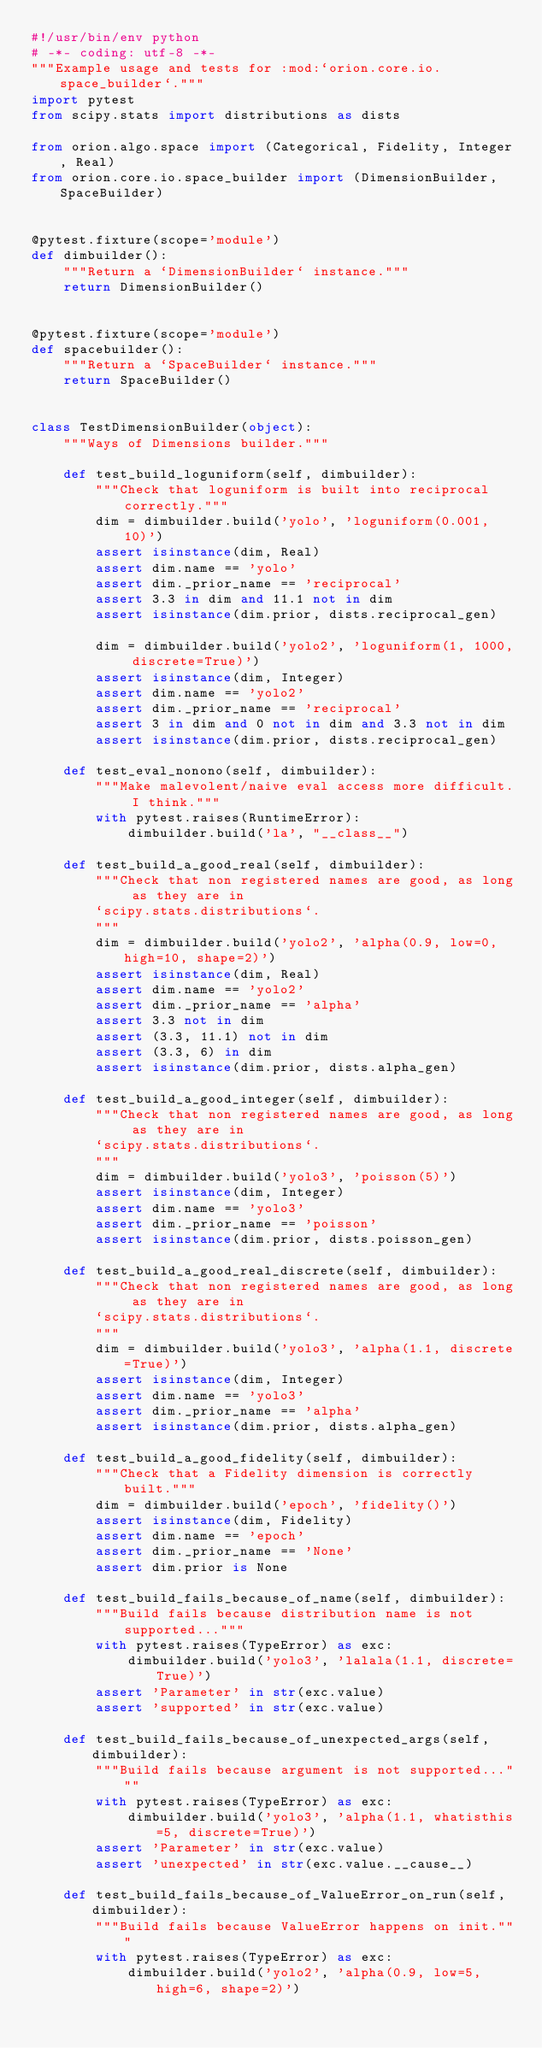<code> <loc_0><loc_0><loc_500><loc_500><_Python_>#!/usr/bin/env python
# -*- coding: utf-8 -*-
"""Example usage and tests for :mod:`orion.core.io.space_builder`."""
import pytest
from scipy.stats import distributions as dists

from orion.algo.space import (Categorical, Fidelity, Integer, Real)
from orion.core.io.space_builder import (DimensionBuilder, SpaceBuilder)


@pytest.fixture(scope='module')
def dimbuilder():
    """Return a `DimensionBuilder` instance."""
    return DimensionBuilder()


@pytest.fixture(scope='module')
def spacebuilder():
    """Return a `SpaceBuilder` instance."""
    return SpaceBuilder()


class TestDimensionBuilder(object):
    """Ways of Dimensions builder."""

    def test_build_loguniform(self, dimbuilder):
        """Check that loguniform is built into reciprocal correctly."""
        dim = dimbuilder.build('yolo', 'loguniform(0.001, 10)')
        assert isinstance(dim, Real)
        assert dim.name == 'yolo'
        assert dim._prior_name == 'reciprocal'
        assert 3.3 in dim and 11.1 not in dim
        assert isinstance(dim.prior, dists.reciprocal_gen)

        dim = dimbuilder.build('yolo2', 'loguniform(1, 1000, discrete=True)')
        assert isinstance(dim, Integer)
        assert dim.name == 'yolo2'
        assert dim._prior_name == 'reciprocal'
        assert 3 in dim and 0 not in dim and 3.3 not in dim
        assert isinstance(dim.prior, dists.reciprocal_gen)

    def test_eval_nonono(self, dimbuilder):
        """Make malevolent/naive eval access more difficult. I think."""
        with pytest.raises(RuntimeError):
            dimbuilder.build('la', "__class__")

    def test_build_a_good_real(self, dimbuilder):
        """Check that non registered names are good, as long as they are in
        `scipy.stats.distributions`.
        """
        dim = dimbuilder.build('yolo2', 'alpha(0.9, low=0, high=10, shape=2)')
        assert isinstance(dim, Real)
        assert dim.name == 'yolo2'
        assert dim._prior_name == 'alpha'
        assert 3.3 not in dim
        assert (3.3, 11.1) not in dim
        assert (3.3, 6) in dim
        assert isinstance(dim.prior, dists.alpha_gen)

    def test_build_a_good_integer(self, dimbuilder):
        """Check that non registered names are good, as long as they are in
        `scipy.stats.distributions`.
        """
        dim = dimbuilder.build('yolo3', 'poisson(5)')
        assert isinstance(dim, Integer)
        assert dim.name == 'yolo3'
        assert dim._prior_name == 'poisson'
        assert isinstance(dim.prior, dists.poisson_gen)

    def test_build_a_good_real_discrete(self, dimbuilder):
        """Check that non registered names are good, as long as they are in
        `scipy.stats.distributions`.
        """
        dim = dimbuilder.build('yolo3', 'alpha(1.1, discrete=True)')
        assert isinstance(dim, Integer)
        assert dim.name == 'yolo3'
        assert dim._prior_name == 'alpha'
        assert isinstance(dim.prior, dists.alpha_gen)

    def test_build_a_good_fidelity(self, dimbuilder):
        """Check that a Fidelity dimension is correctly built."""
        dim = dimbuilder.build('epoch', 'fidelity()')
        assert isinstance(dim, Fidelity)
        assert dim.name == 'epoch'
        assert dim._prior_name == 'None'
        assert dim.prior is None

    def test_build_fails_because_of_name(self, dimbuilder):
        """Build fails because distribution name is not supported..."""
        with pytest.raises(TypeError) as exc:
            dimbuilder.build('yolo3', 'lalala(1.1, discrete=True)')
        assert 'Parameter' in str(exc.value)
        assert 'supported' in str(exc.value)

    def test_build_fails_because_of_unexpected_args(self, dimbuilder):
        """Build fails because argument is not supported..."""
        with pytest.raises(TypeError) as exc:
            dimbuilder.build('yolo3', 'alpha(1.1, whatisthis=5, discrete=True)')
        assert 'Parameter' in str(exc.value)
        assert 'unexpected' in str(exc.value.__cause__)

    def test_build_fails_because_of_ValueError_on_run(self, dimbuilder):
        """Build fails because ValueError happens on init."""
        with pytest.raises(TypeError) as exc:
            dimbuilder.build('yolo2', 'alpha(0.9, low=5, high=6, shape=2)')</code> 